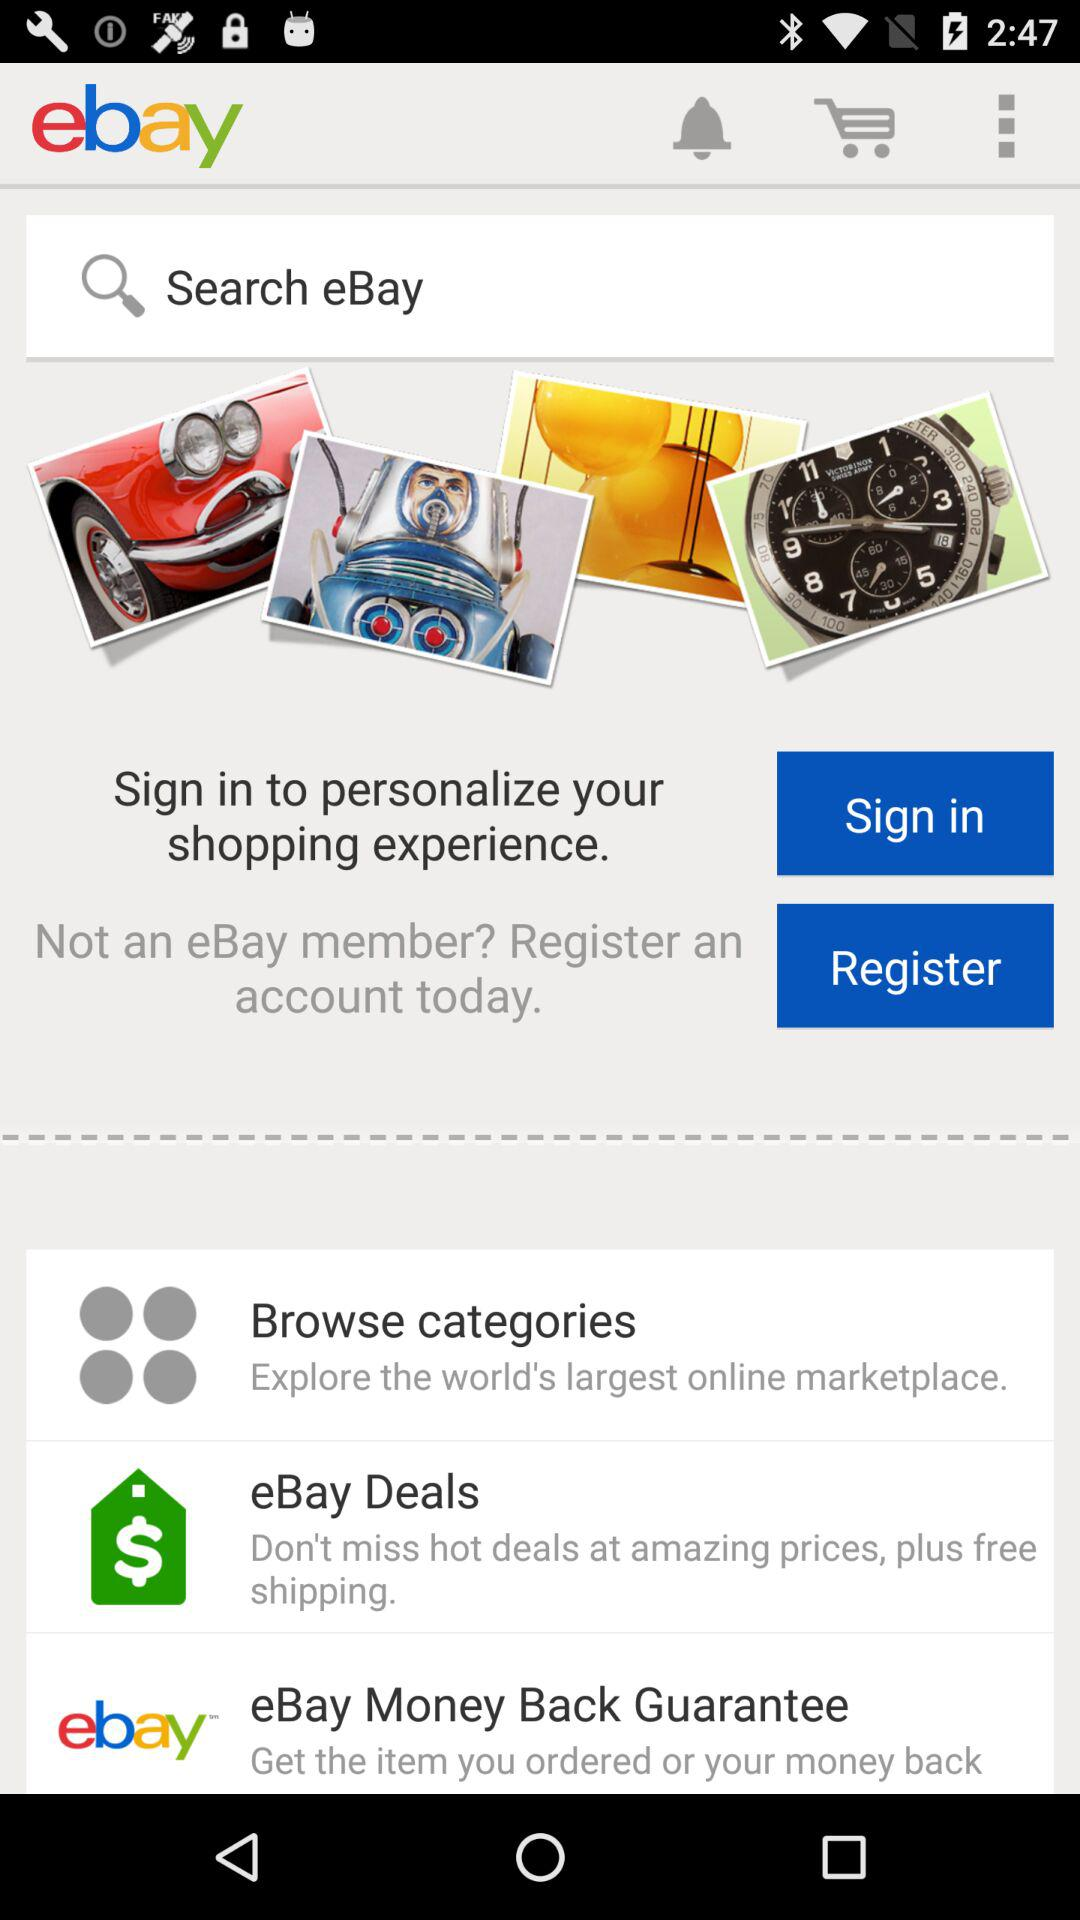What is the name of the application? The application name is "ebay". 